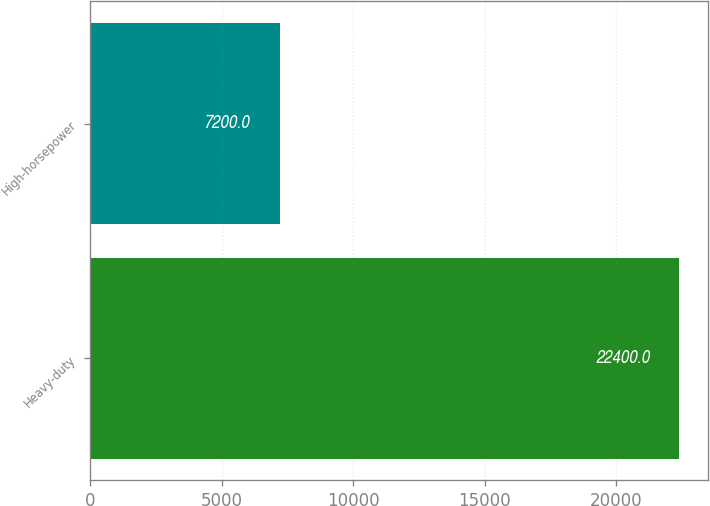Convert chart to OTSL. <chart><loc_0><loc_0><loc_500><loc_500><bar_chart><fcel>Heavy-duty<fcel>High-horsepower<nl><fcel>22400<fcel>7200<nl></chart> 